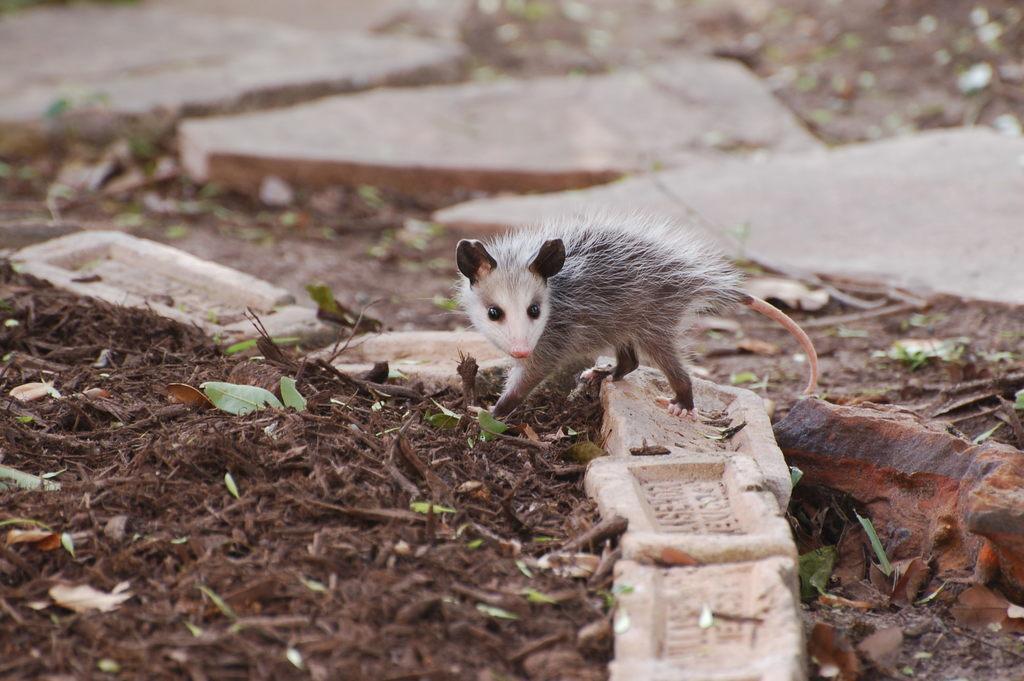Can you describe this image briefly? In this image we can see there is a small rat on the ground and also there are some leaves on the ground. 